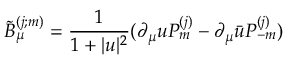<formula> <loc_0><loc_0><loc_500><loc_500>\tilde { B } _ { \mu } ^ { ( j ; m ) } = \frac { 1 } { 1 + | u | ^ { 2 } } ( \partial _ { \mu } u P _ { m } ^ { ( j ) } - \partial _ { \mu } \bar { u } P _ { - m } ^ { ( j ) } )</formula> 